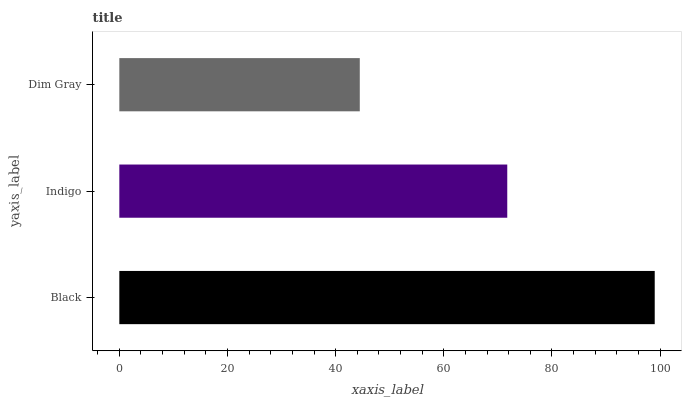Is Dim Gray the minimum?
Answer yes or no. Yes. Is Black the maximum?
Answer yes or no. Yes. Is Indigo the minimum?
Answer yes or no. No. Is Indigo the maximum?
Answer yes or no. No. Is Black greater than Indigo?
Answer yes or no. Yes. Is Indigo less than Black?
Answer yes or no. Yes. Is Indigo greater than Black?
Answer yes or no. No. Is Black less than Indigo?
Answer yes or no. No. Is Indigo the high median?
Answer yes or no. Yes. Is Indigo the low median?
Answer yes or no. Yes. Is Black the high median?
Answer yes or no. No. Is Dim Gray the low median?
Answer yes or no. No. 